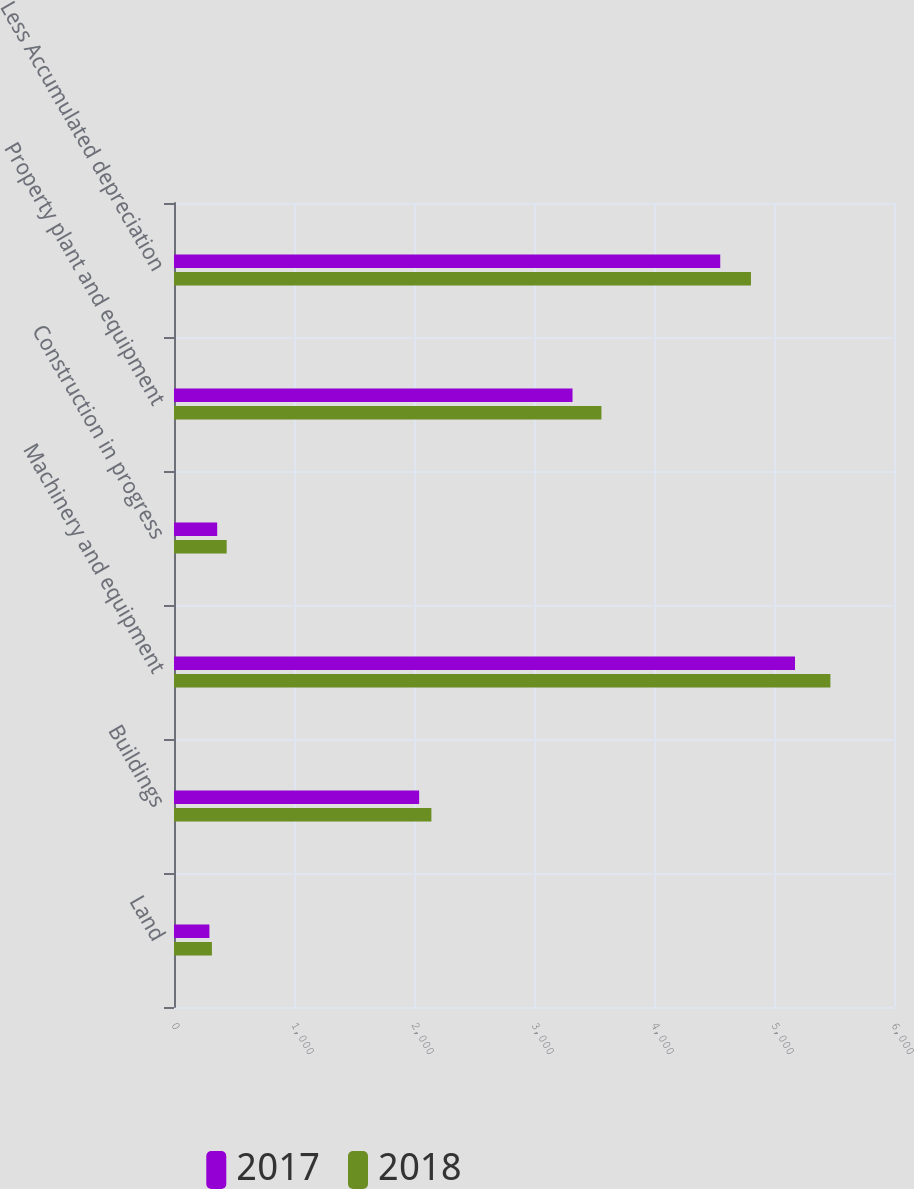<chart> <loc_0><loc_0><loc_500><loc_500><stacked_bar_chart><ecel><fcel>Land<fcel>Buildings<fcel>Machinery and equipment<fcel>Construction in progress<fcel>Property plant and equipment<fcel>Less Accumulated depreciation<nl><fcel>2017<fcel>295<fcel>2043<fcel>5175<fcel>360<fcel>3321<fcel>4552<nl><fcel>2018<fcel>316<fcel>2145<fcel>5470<fcel>439<fcel>3562<fcel>4808<nl></chart> 